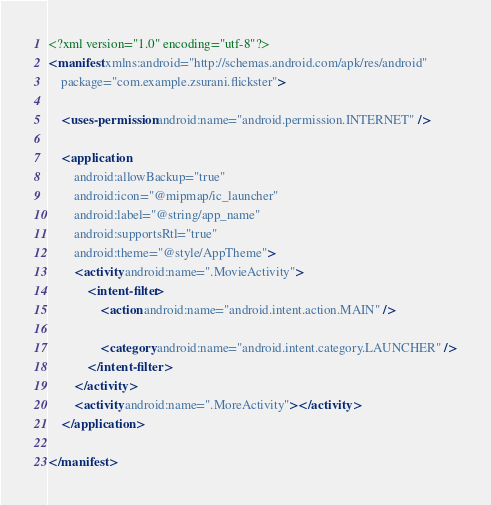Convert code to text. <code><loc_0><loc_0><loc_500><loc_500><_XML_><?xml version="1.0" encoding="utf-8"?>
<manifest xmlns:android="http://schemas.android.com/apk/res/android"
    package="com.example.zsurani.flickster">

    <uses-permission android:name="android.permission.INTERNET" />

    <application
        android:allowBackup="true"
        android:icon="@mipmap/ic_launcher"
        android:label="@string/app_name"
        android:supportsRtl="true"
        android:theme="@style/AppTheme">
        <activity android:name=".MovieActivity">
            <intent-filter>
                <action android:name="android.intent.action.MAIN" />

                <category android:name="android.intent.category.LAUNCHER" />
            </intent-filter>
        </activity>
        <activity android:name=".MoreActivity"></activity>
    </application>

</manifest></code> 